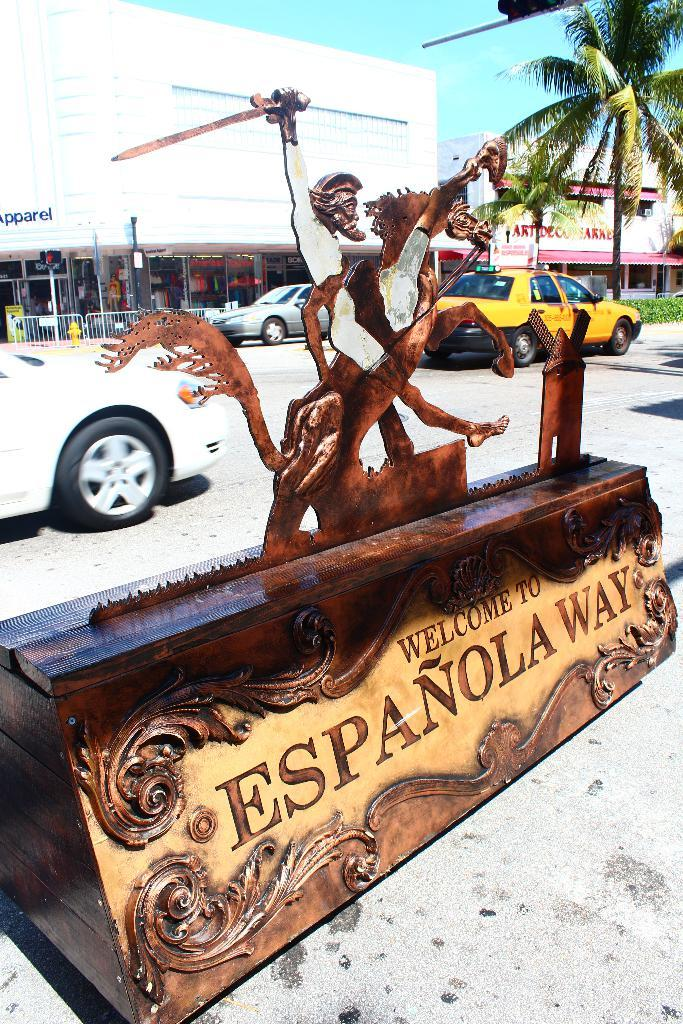<image>
Provide a brief description of the given image. A large wood sculpture that says Welcome to Espanola Way. 